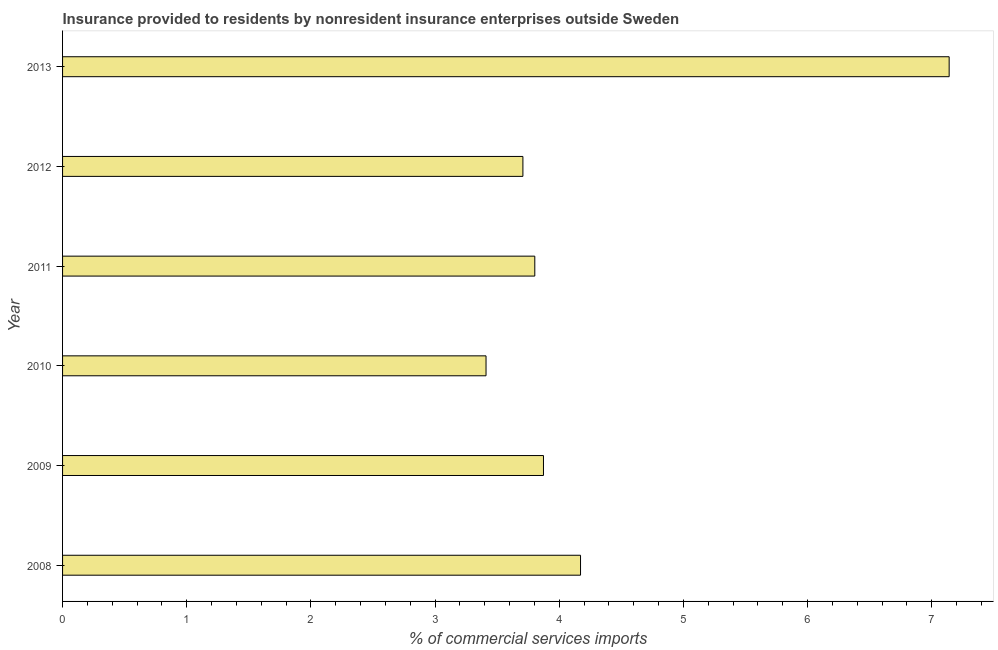Does the graph contain grids?
Offer a very short reply. No. What is the title of the graph?
Your response must be concise. Insurance provided to residents by nonresident insurance enterprises outside Sweden. What is the label or title of the X-axis?
Your answer should be compact. % of commercial services imports. What is the label or title of the Y-axis?
Provide a succinct answer. Year. What is the insurance provided by non-residents in 2010?
Give a very brief answer. 3.41. Across all years, what is the maximum insurance provided by non-residents?
Ensure brevity in your answer.  7.14. Across all years, what is the minimum insurance provided by non-residents?
Ensure brevity in your answer.  3.41. In which year was the insurance provided by non-residents maximum?
Your answer should be very brief. 2013. In which year was the insurance provided by non-residents minimum?
Your answer should be compact. 2010. What is the sum of the insurance provided by non-residents?
Ensure brevity in your answer.  26.11. What is the difference between the insurance provided by non-residents in 2008 and 2010?
Your answer should be compact. 0.76. What is the average insurance provided by non-residents per year?
Your response must be concise. 4.35. What is the median insurance provided by non-residents?
Give a very brief answer. 3.84. What is the ratio of the insurance provided by non-residents in 2009 to that in 2011?
Your answer should be very brief. 1.02. Is the difference between the insurance provided by non-residents in 2008 and 2012 greater than the difference between any two years?
Make the answer very short. No. What is the difference between the highest and the second highest insurance provided by non-residents?
Offer a very short reply. 2.97. What is the difference between the highest and the lowest insurance provided by non-residents?
Your answer should be compact. 3.73. In how many years, is the insurance provided by non-residents greater than the average insurance provided by non-residents taken over all years?
Provide a short and direct response. 1. Are all the bars in the graph horizontal?
Give a very brief answer. Yes. What is the difference between two consecutive major ticks on the X-axis?
Your answer should be compact. 1. Are the values on the major ticks of X-axis written in scientific E-notation?
Provide a succinct answer. No. What is the % of commercial services imports of 2008?
Your response must be concise. 4.17. What is the % of commercial services imports of 2009?
Make the answer very short. 3.87. What is the % of commercial services imports of 2010?
Ensure brevity in your answer.  3.41. What is the % of commercial services imports in 2011?
Provide a short and direct response. 3.8. What is the % of commercial services imports of 2012?
Give a very brief answer. 3.71. What is the % of commercial services imports in 2013?
Give a very brief answer. 7.14. What is the difference between the % of commercial services imports in 2008 and 2009?
Give a very brief answer. 0.3. What is the difference between the % of commercial services imports in 2008 and 2010?
Provide a succinct answer. 0.76. What is the difference between the % of commercial services imports in 2008 and 2011?
Offer a terse response. 0.37. What is the difference between the % of commercial services imports in 2008 and 2012?
Offer a very short reply. 0.46. What is the difference between the % of commercial services imports in 2008 and 2013?
Your answer should be compact. -2.97. What is the difference between the % of commercial services imports in 2009 and 2010?
Your response must be concise. 0.46. What is the difference between the % of commercial services imports in 2009 and 2011?
Provide a succinct answer. 0.07. What is the difference between the % of commercial services imports in 2009 and 2012?
Give a very brief answer. 0.17. What is the difference between the % of commercial services imports in 2009 and 2013?
Offer a terse response. -3.27. What is the difference between the % of commercial services imports in 2010 and 2011?
Offer a terse response. -0.39. What is the difference between the % of commercial services imports in 2010 and 2012?
Your answer should be compact. -0.3. What is the difference between the % of commercial services imports in 2010 and 2013?
Provide a succinct answer. -3.73. What is the difference between the % of commercial services imports in 2011 and 2012?
Provide a short and direct response. 0.1. What is the difference between the % of commercial services imports in 2011 and 2013?
Offer a very short reply. -3.34. What is the difference between the % of commercial services imports in 2012 and 2013?
Provide a short and direct response. -3.43. What is the ratio of the % of commercial services imports in 2008 to that in 2009?
Offer a very short reply. 1.08. What is the ratio of the % of commercial services imports in 2008 to that in 2010?
Provide a short and direct response. 1.22. What is the ratio of the % of commercial services imports in 2008 to that in 2011?
Provide a short and direct response. 1.1. What is the ratio of the % of commercial services imports in 2008 to that in 2013?
Ensure brevity in your answer.  0.58. What is the ratio of the % of commercial services imports in 2009 to that in 2010?
Your answer should be compact. 1.14. What is the ratio of the % of commercial services imports in 2009 to that in 2011?
Provide a short and direct response. 1.02. What is the ratio of the % of commercial services imports in 2009 to that in 2012?
Make the answer very short. 1.04. What is the ratio of the % of commercial services imports in 2009 to that in 2013?
Provide a short and direct response. 0.54. What is the ratio of the % of commercial services imports in 2010 to that in 2011?
Provide a succinct answer. 0.9. What is the ratio of the % of commercial services imports in 2010 to that in 2012?
Ensure brevity in your answer.  0.92. What is the ratio of the % of commercial services imports in 2010 to that in 2013?
Your answer should be compact. 0.48. What is the ratio of the % of commercial services imports in 2011 to that in 2013?
Provide a succinct answer. 0.53. What is the ratio of the % of commercial services imports in 2012 to that in 2013?
Your response must be concise. 0.52. 